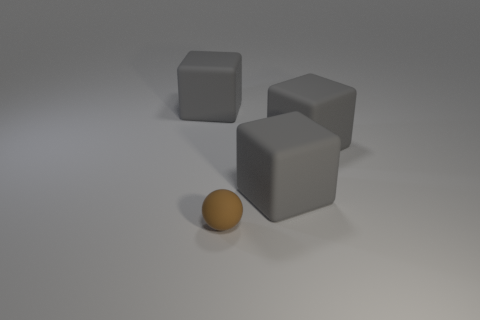Are there any tiny purple cubes made of the same material as the ball?
Your answer should be very brief. No. Are there more tiny green shiny blocks than blocks?
Your response must be concise. No. Do the gray rubber thing that is on the left side of the sphere and the brown rubber ball have the same size?
Provide a short and direct response. No. Is there any other thing that is the same size as the brown matte ball?
Offer a very short reply. No. Is there any other thing that is the same shape as the tiny object?
Your answer should be very brief. No. The large object that is on the left side of the small brown thing has what shape?
Your answer should be compact. Cube. How many big cubes are left of the gray rubber thing left of the small sphere?
Give a very brief answer. 0. How many rubber objects are either big cyan things or large gray cubes?
Your response must be concise. 3. What is the brown sphere made of?
Make the answer very short. Rubber. What number of things are big brown rubber things or rubber objects that are right of the small object?
Offer a very short reply. 2. 